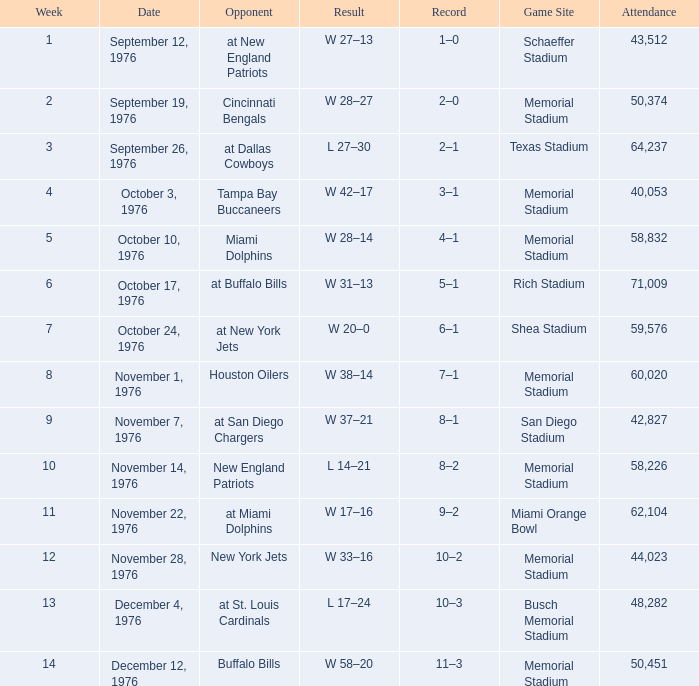What was the attendance count at the miami orange bowl game? 62104.0. 